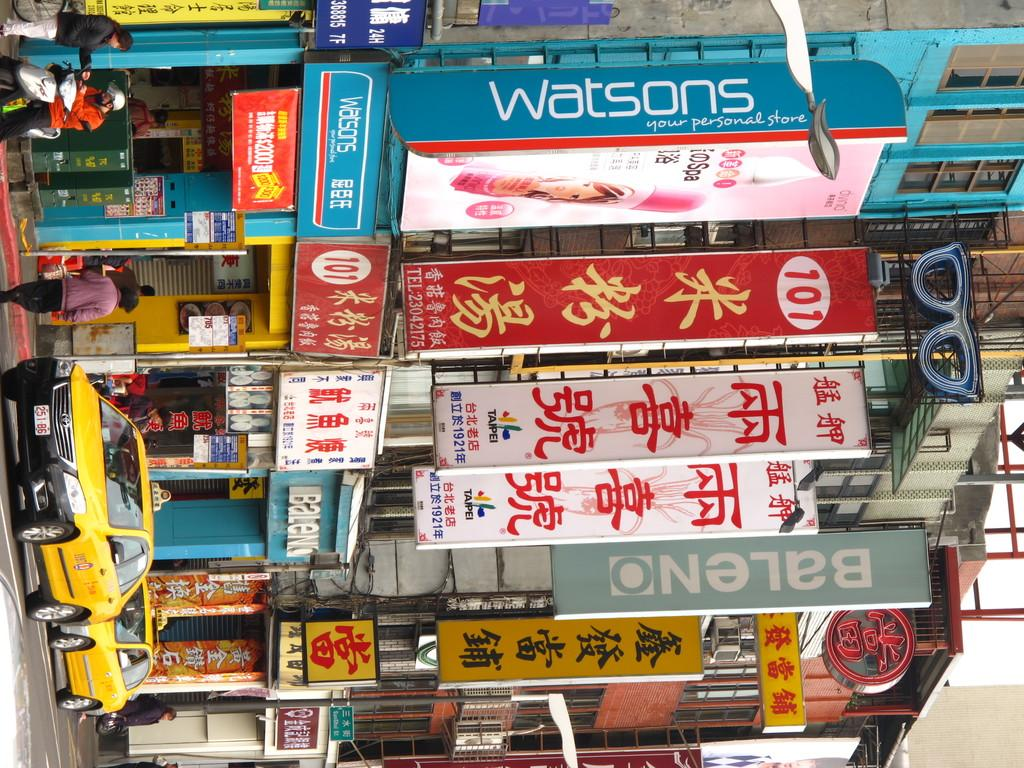Provide a one-sentence caption for the provided image. A street shot with many banners hanging including Watsons. 